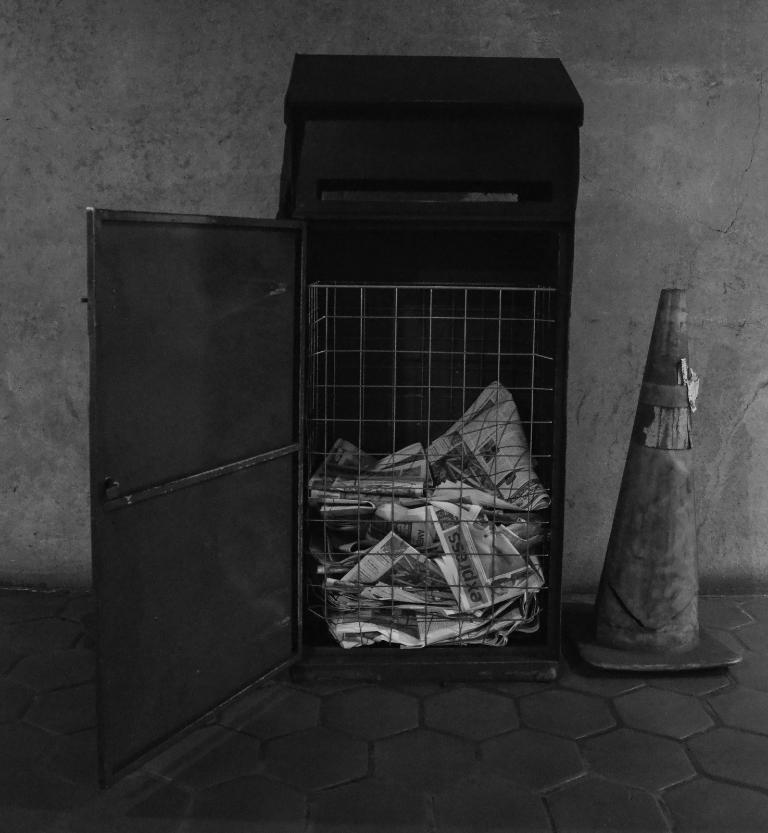Please provide a concise description of this image. In this image I can see a box and in it I can see number of newspapers. I can also see a cage, a traffic cone and on these papers I can see something is written. I can also see this image is black and white in colour. 